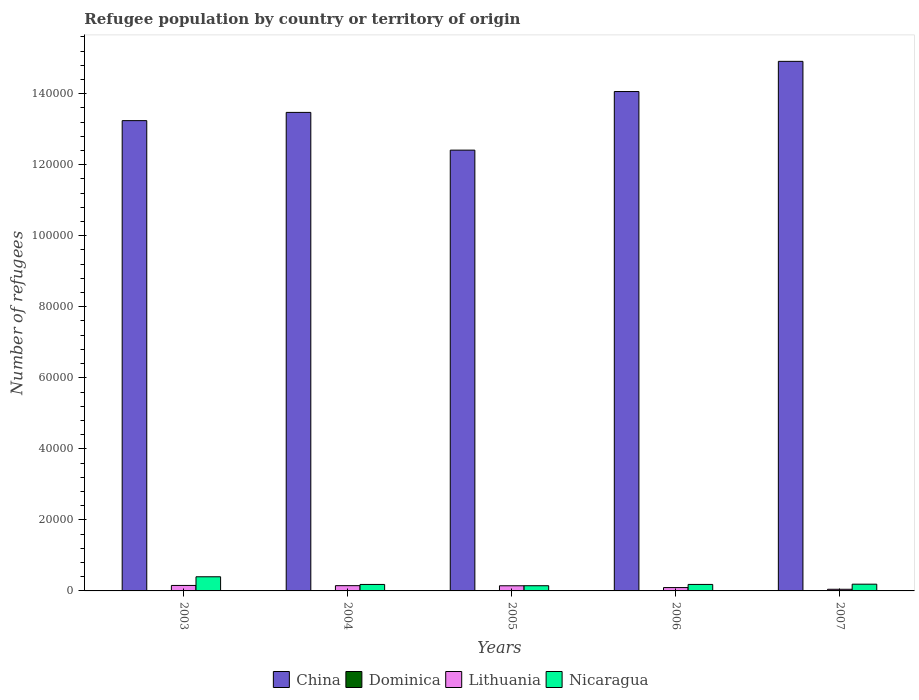How many different coloured bars are there?
Keep it short and to the point. 4. How many bars are there on the 3rd tick from the right?
Your answer should be very brief. 4. What is the number of refugees in Lithuania in 2005?
Offer a terse response. 1448. Across all years, what is the maximum number of refugees in Dominica?
Make the answer very short. 58. Across all years, what is the minimum number of refugees in Nicaragua?
Ensure brevity in your answer.  1463. In which year was the number of refugees in Dominica maximum?
Your answer should be compact. 2007. In which year was the number of refugees in China minimum?
Your answer should be compact. 2005. What is the total number of refugees in Lithuania in the graph?
Your answer should be compact. 5879. What is the difference between the number of refugees in Lithuania in 2003 and that in 2004?
Ensure brevity in your answer.  59. What is the difference between the number of refugees in Lithuania in 2007 and the number of refugees in Dominica in 2005?
Give a very brief answer. 436. What is the average number of refugees in China per year?
Provide a succinct answer. 1.36e+05. In the year 2007, what is the difference between the number of refugees in Lithuania and number of refugees in China?
Offer a terse response. -1.49e+05. In how many years, is the number of refugees in Lithuania greater than 144000?
Offer a very short reply. 0. What is the ratio of the number of refugees in Nicaragua in 2004 to that in 2007?
Provide a succinct answer. 0.96. Is the number of refugees in Lithuania in 2004 less than that in 2007?
Your answer should be compact. No. Is the difference between the number of refugees in Lithuania in 2004 and 2005 greater than the difference between the number of refugees in China in 2004 and 2005?
Offer a terse response. No. What is the difference between the highest and the lowest number of refugees in Dominica?
Provide a succinct answer. 41. In how many years, is the number of refugees in Lithuania greater than the average number of refugees in Lithuania taken over all years?
Provide a succinct answer. 3. Is the sum of the number of refugees in Lithuania in 2005 and 2007 greater than the maximum number of refugees in Nicaragua across all years?
Ensure brevity in your answer.  No. What does the 2nd bar from the left in 2004 represents?
Your response must be concise. Dominica. What does the 3rd bar from the right in 2003 represents?
Provide a succinct answer. Dominica. How many bars are there?
Offer a very short reply. 20. What is the difference between two consecutive major ticks on the Y-axis?
Provide a succinct answer. 2.00e+04. Are the values on the major ticks of Y-axis written in scientific E-notation?
Offer a very short reply. No. Does the graph contain any zero values?
Provide a succinct answer. No. Does the graph contain grids?
Make the answer very short. No. What is the title of the graph?
Give a very brief answer. Refugee population by country or territory of origin. What is the label or title of the X-axis?
Provide a succinct answer. Years. What is the label or title of the Y-axis?
Your answer should be compact. Number of refugees. What is the Number of refugees in China in 2003?
Provide a succinct answer. 1.32e+05. What is the Number of refugees of Dominica in 2003?
Provide a succinct answer. 17. What is the Number of refugees in Lithuania in 2003?
Give a very brief answer. 1541. What is the Number of refugees of Nicaragua in 2003?
Your response must be concise. 3983. What is the Number of refugees of China in 2004?
Ensure brevity in your answer.  1.35e+05. What is the Number of refugees of Lithuania in 2004?
Your answer should be very brief. 1482. What is the Number of refugees of Nicaragua in 2004?
Provide a short and direct response. 1822. What is the Number of refugees of China in 2005?
Provide a succinct answer. 1.24e+05. What is the Number of refugees in Lithuania in 2005?
Keep it short and to the point. 1448. What is the Number of refugees of Nicaragua in 2005?
Provide a succinct answer. 1463. What is the Number of refugees in China in 2006?
Give a very brief answer. 1.41e+05. What is the Number of refugees in Dominica in 2006?
Provide a succinct answer. 49. What is the Number of refugees in Lithuania in 2006?
Your answer should be compact. 942. What is the Number of refugees of Nicaragua in 2006?
Make the answer very short. 1828. What is the Number of refugees of China in 2007?
Provide a short and direct response. 1.49e+05. What is the Number of refugees of Lithuania in 2007?
Give a very brief answer. 466. What is the Number of refugees in Nicaragua in 2007?
Provide a short and direct response. 1900. Across all years, what is the maximum Number of refugees in China?
Offer a terse response. 1.49e+05. Across all years, what is the maximum Number of refugees of Lithuania?
Keep it short and to the point. 1541. Across all years, what is the maximum Number of refugees of Nicaragua?
Your answer should be very brief. 3983. Across all years, what is the minimum Number of refugees in China?
Provide a short and direct response. 1.24e+05. Across all years, what is the minimum Number of refugees of Dominica?
Your answer should be compact. 17. Across all years, what is the minimum Number of refugees in Lithuania?
Give a very brief answer. 466. Across all years, what is the minimum Number of refugees in Nicaragua?
Your response must be concise. 1463. What is the total Number of refugees of China in the graph?
Keep it short and to the point. 6.81e+05. What is the total Number of refugees in Dominica in the graph?
Offer a very short reply. 179. What is the total Number of refugees in Lithuania in the graph?
Keep it short and to the point. 5879. What is the total Number of refugees in Nicaragua in the graph?
Keep it short and to the point. 1.10e+04. What is the difference between the Number of refugees of China in 2003 and that in 2004?
Your response must be concise. -2318. What is the difference between the Number of refugees in Lithuania in 2003 and that in 2004?
Your response must be concise. 59. What is the difference between the Number of refugees of Nicaragua in 2003 and that in 2004?
Make the answer very short. 2161. What is the difference between the Number of refugees of China in 2003 and that in 2005?
Offer a terse response. 8305. What is the difference between the Number of refugees of Dominica in 2003 and that in 2005?
Provide a succinct answer. -13. What is the difference between the Number of refugees in Lithuania in 2003 and that in 2005?
Provide a succinct answer. 93. What is the difference between the Number of refugees in Nicaragua in 2003 and that in 2005?
Your answer should be very brief. 2520. What is the difference between the Number of refugees of China in 2003 and that in 2006?
Offer a very short reply. -8192. What is the difference between the Number of refugees in Dominica in 2003 and that in 2006?
Make the answer very short. -32. What is the difference between the Number of refugees of Lithuania in 2003 and that in 2006?
Give a very brief answer. 599. What is the difference between the Number of refugees in Nicaragua in 2003 and that in 2006?
Your response must be concise. 2155. What is the difference between the Number of refugees in China in 2003 and that in 2007?
Ensure brevity in your answer.  -1.67e+04. What is the difference between the Number of refugees of Dominica in 2003 and that in 2007?
Offer a terse response. -41. What is the difference between the Number of refugees of Lithuania in 2003 and that in 2007?
Your response must be concise. 1075. What is the difference between the Number of refugees in Nicaragua in 2003 and that in 2007?
Ensure brevity in your answer.  2083. What is the difference between the Number of refugees in China in 2004 and that in 2005?
Provide a short and direct response. 1.06e+04. What is the difference between the Number of refugees of Nicaragua in 2004 and that in 2005?
Your answer should be compact. 359. What is the difference between the Number of refugees in China in 2004 and that in 2006?
Provide a succinct answer. -5874. What is the difference between the Number of refugees of Lithuania in 2004 and that in 2006?
Offer a very short reply. 540. What is the difference between the Number of refugees in China in 2004 and that in 2007?
Give a very brief answer. -1.44e+04. What is the difference between the Number of refugees of Dominica in 2004 and that in 2007?
Make the answer very short. -33. What is the difference between the Number of refugees in Lithuania in 2004 and that in 2007?
Provide a short and direct response. 1016. What is the difference between the Number of refugees of Nicaragua in 2004 and that in 2007?
Keep it short and to the point. -78. What is the difference between the Number of refugees of China in 2005 and that in 2006?
Provide a succinct answer. -1.65e+04. What is the difference between the Number of refugees of Dominica in 2005 and that in 2006?
Provide a succinct answer. -19. What is the difference between the Number of refugees of Lithuania in 2005 and that in 2006?
Your answer should be very brief. 506. What is the difference between the Number of refugees in Nicaragua in 2005 and that in 2006?
Your answer should be very brief. -365. What is the difference between the Number of refugees of China in 2005 and that in 2007?
Provide a succinct answer. -2.50e+04. What is the difference between the Number of refugees of Dominica in 2005 and that in 2007?
Provide a succinct answer. -28. What is the difference between the Number of refugees in Lithuania in 2005 and that in 2007?
Your answer should be compact. 982. What is the difference between the Number of refugees of Nicaragua in 2005 and that in 2007?
Give a very brief answer. -437. What is the difference between the Number of refugees in China in 2006 and that in 2007?
Provide a short and direct response. -8497. What is the difference between the Number of refugees of Dominica in 2006 and that in 2007?
Provide a short and direct response. -9. What is the difference between the Number of refugees of Lithuania in 2006 and that in 2007?
Ensure brevity in your answer.  476. What is the difference between the Number of refugees in Nicaragua in 2006 and that in 2007?
Your answer should be very brief. -72. What is the difference between the Number of refugees in China in 2003 and the Number of refugees in Dominica in 2004?
Ensure brevity in your answer.  1.32e+05. What is the difference between the Number of refugees of China in 2003 and the Number of refugees of Lithuania in 2004?
Your response must be concise. 1.31e+05. What is the difference between the Number of refugees of China in 2003 and the Number of refugees of Nicaragua in 2004?
Your answer should be very brief. 1.31e+05. What is the difference between the Number of refugees in Dominica in 2003 and the Number of refugees in Lithuania in 2004?
Your answer should be very brief. -1465. What is the difference between the Number of refugees of Dominica in 2003 and the Number of refugees of Nicaragua in 2004?
Your answer should be compact. -1805. What is the difference between the Number of refugees of Lithuania in 2003 and the Number of refugees of Nicaragua in 2004?
Ensure brevity in your answer.  -281. What is the difference between the Number of refugees of China in 2003 and the Number of refugees of Dominica in 2005?
Provide a succinct answer. 1.32e+05. What is the difference between the Number of refugees of China in 2003 and the Number of refugees of Lithuania in 2005?
Your answer should be very brief. 1.31e+05. What is the difference between the Number of refugees in China in 2003 and the Number of refugees in Nicaragua in 2005?
Your answer should be compact. 1.31e+05. What is the difference between the Number of refugees of Dominica in 2003 and the Number of refugees of Lithuania in 2005?
Offer a terse response. -1431. What is the difference between the Number of refugees in Dominica in 2003 and the Number of refugees in Nicaragua in 2005?
Provide a short and direct response. -1446. What is the difference between the Number of refugees in Lithuania in 2003 and the Number of refugees in Nicaragua in 2005?
Your response must be concise. 78. What is the difference between the Number of refugees of China in 2003 and the Number of refugees of Dominica in 2006?
Keep it short and to the point. 1.32e+05. What is the difference between the Number of refugees of China in 2003 and the Number of refugees of Lithuania in 2006?
Your response must be concise. 1.31e+05. What is the difference between the Number of refugees in China in 2003 and the Number of refugees in Nicaragua in 2006?
Ensure brevity in your answer.  1.31e+05. What is the difference between the Number of refugees of Dominica in 2003 and the Number of refugees of Lithuania in 2006?
Give a very brief answer. -925. What is the difference between the Number of refugees of Dominica in 2003 and the Number of refugees of Nicaragua in 2006?
Your answer should be compact. -1811. What is the difference between the Number of refugees of Lithuania in 2003 and the Number of refugees of Nicaragua in 2006?
Make the answer very short. -287. What is the difference between the Number of refugees of China in 2003 and the Number of refugees of Dominica in 2007?
Provide a succinct answer. 1.32e+05. What is the difference between the Number of refugees of China in 2003 and the Number of refugees of Lithuania in 2007?
Your answer should be very brief. 1.32e+05. What is the difference between the Number of refugees of China in 2003 and the Number of refugees of Nicaragua in 2007?
Ensure brevity in your answer.  1.31e+05. What is the difference between the Number of refugees of Dominica in 2003 and the Number of refugees of Lithuania in 2007?
Offer a very short reply. -449. What is the difference between the Number of refugees in Dominica in 2003 and the Number of refugees in Nicaragua in 2007?
Ensure brevity in your answer.  -1883. What is the difference between the Number of refugees in Lithuania in 2003 and the Number of refugees in Nicaragua in 2007?
Keep it short and to the point. -359. What is the difference between the Number of refugees in China in 2004 and the Number of refugees in Dominica in 2005?
Provide a succinct answer. 1.35e+05. What is the difference between the Number of refugees of China in 2004 and the Number of refugees of Lithuania in 2005?
Your response must be concise. 1.33e+05. What is the difference between the Number of refugees of China in 2004 and the Number of refugees of Nicaragua in 2005?
Provide a short and direct response. 1.33e+05. What is the difference between the Number of refugees of Dominica in 2004 and the Number of refugees of Lithuania in 2005?
Offer a very short reply. -1423. What is the difference between the Number of refugees of Dominica in 2004 and the Number of refugees of Nicaragua in 2005?
Your answer should be very brief. -1438. What is the difference between the Number of refugees in Lithuania in 2004 and the Number of refugees in Nicaragua in 2005?
Make the answer very short. 19. What is the difference between the Number of refugees of China in 2004 and the Number of refugees of Dominica in 2006?
Provide a short and direct response. 1.35e+05. What is the difference between the Number of refugees in China in 2004 and the Number of refugees in Lithuania in 2006?
Offer a terse response. 1.34e+05. What is the difference between the Number of refugees in China in 2004 and the Number of refugees in Nicaragua in 2006?
Your answer should be very brief. 1.33e+05. What is the difference between the Number of refugees of Dominica in 2004 and the Number of refugees of Lithuania in 2006?
Your answer should be very brief. -917. What is the difference between the Number of refugees of Dominica in 2004 and the Number of refugees of Nicaragua in 2006?
Provide a short and direct response. -1803. What is the difference between the Number of refugees in Lithuania in 2004 and the Number of refugees in Nicaragua in 2006?
Your answer should be compact. -346. What is the difference between the Number of refugees in China in 2004 and the Number of refugees in Dominica in 2007?
Your answer should be very brief. 1.35e+05. What is the difference between the Number of refugees of China in 2004 and the Number of refugees of Lithuania in 2007?
Offer a terse response. 1.34e+05. What is the difference between the Number of refugees in China in 2004 and the Number of refugees in Nicaragua in 2007?
Offer a very short reply. 1.33e+05. What is the difference between the Number of refugees of Dominica in 2004 and the Number of refugees of Lithuania in 2007?
Your answer should be compact. -441. What is the difference between the Number of refugees in Dominica in 2004 and the Number of refugees in Nicaragua in 2007?
Your answer should be very brief. -1875. What is the difference between the Number of refugees of Lithuania in 2004 and the Number of refugees of Nicaragua in 2007?
Offer a terse response. -418. What is the difference between the Number of refugees in China in 2005 and the Number of refugees in Dominica in 2006?
Keep it short and to the point. 1.24e+05. What is the difference between the Number of refugees in China in 2005 and the Number of refugees in Lithuania in 2006?
Ensure brevity in your answer.  1.23e+05. What is the difference between the Number of refugees of China in 2005 and the Number of refugees of Nicaragua in 2006?
Your answer should be compact. 1.22e+05. What is the difference between the Number of refugees in Dominica in 2005 and the Number of refugees in Lithuania in 2006?
Provide a succinct answer. -912. What is the difference between the Number of refugees of Dominica in 2005 and the Number of refugees of Nicaragua in 2006?
Your answer should be very brief. -1798. What is the difference between the Number of refugees of Lithuania in 2005 and the Number of refugees of Nicaragua in 2006?
Give a very brief answer. -380. What is the difference between the Number of refugees of China in 2005 and the Number of refugees of Dominica in 2007?
Your answer should be compact. 1.24e+05. What is the difference between the Number of refugees in China in 2005 and the Number of refugees in Lithuania in 2007?
Your answer should be very brief. 1.24e+05. What is the difference between the Number of refugees in China in 2005 and the Number of refugees in Nicaragua in 2007?
Keep it short and to the point. 1.22e+05. What is the difference between the Number of refugees in Dominica in 2005 and the Number of refugees in Lithuania in 2007?
Your response must be concise. -436. What is the difference between the Number of refugees of Dominica in 2005 and the Number of refugees of Nicaragua in 2007?
Your response must be concise. -1870. What is the difference between the Number of refugees in Lithuania in 2005 and the Number of refugees in Nicaragua in 2007?
Your answer should be very brief. -452. What is the difference between the Number of refugees of China in 2006 and the Number of refugees of Dominica in 2007?
Provide a short and direct response. 1.41e+05. What is the difference between the Number of refugees in China in 2006 and the Number of refugees in Lithuania in 2007?
Your answer should be very brief. 1.40e+05. What is the difference between the Number of refugees in China in 2006 and the Number of refugees in Nicaragua in 2007?
Offer a terse response. 1.39e+05. What is the difference between the Number of refugees of Dominica in 2006 and the Number of refugees of Lithuania in 2007?
Ensure brevity in your answer.  -417. What is the difference between the Number of refugees of Dominica in 2006 and the Number of refugees of Nicaragua in 2007?
Offer a terse response. -1851. What is the difference between the Number of refugees in Lithuania in 2006 and the Number of refugees in Nicaragua in 2007?
Ensure brevity in your answer.  -958. What is the average Number of refugees in China per year?
Offer a terse response. 1.36e+05. What is the average Number of refugees in Dominica per year?
Provide a short and direct response. 35.8. What is the average Number of refugees of Lithuania per year?
Offer a terse response. 1175.8. What is the average Number of refugees of Nicaragua per year?
Ensure brevity in your answer.  2199.2. In the year 2003, what is the difference between the Number of refugees of China and Number of refugees of Dominica?
Offer a terse response. 1.32e+05. In the year 2003, what is the difference between the Number of refugees of China and Number of refugees of Lithuania?
Make the answer very short. 1.31e+05. In the year 2003, what is the difference between the Number of refugees in China and Number of refugees in Nicaragua?
Your answer should be compact. 1.28e+05. In the year 2003, what is the difference between the Number of refugees in Dominica and Number of refugees in Lithuania?
Make the answer very short. -1524. In the year 2003, what is the difference between the Number of refugees of Dominica and Number of refugees of Nicaragua?
Your answer should be very brief. -3966. In the year 2003, what is the difference between the Number of refugees in Lithuania and Number of refugees in Nicaragua?
Provide a short and direct response. -2442. In the year 2004, what is the difference between the Number of refugees in China and Number of refugees in Dominica?
Keep it short and to the point. 1.35e+05. In the year 2004, what is the difference between the Number of refugees in China and Number of refugees in Lithuania?
Give a very brief answer. 1.33e+05. In the year 2004, what is the difference between the Number of refugees of China and Number of refugees of Nicaragua?
Give a very brief answer. 1.33e+05. In the year 2004, what is the difference between the Number of refugees of Dominica and Number of refugees of Lithuania?
Your answer should be compact. -1457. In the year 2004, what is the difference between the Number of refugees in Dominica and Number of refugees in Nicaragua?
Provide a succinct answer. -1797. In the year 2004, what is the difference between the Number of refugees in Lithuania and Number of refugees in Nicaragua?
Your response must be concise. -340. In the year 2005, what is the difference between the Number of refugees of China and Number of refugees of Dominica?
Offer a terse response. 1.24e+05. In the year 2005, what is the difference between the Number of refugees of China and Number of refugees of Lithuania?
Provide a succinct answer. 1.23e+05. In the year 2005, what is the difference between the Number of refugees of China and Number of refugees of Nicaragua?
Make the answer very short. 1.23e+05. In the year 2005, what is the difference between the Number of refugees in Dominica and Number of refugees in Lithuania?
Provide a short and direct response. -1418. In the year 2005, what is the difference between the Number of refugees in Dominica and Number of refugees in Nicaragua?
Make the answer very short. -1433. In the year 2005, what is the difference between the Number of refugees of Lithuania and Number of refugees of Nicaragua?
Your response must be concise. -15. In the year 2006, what is the difference between the Number of refugees in China and Number of refugees in Dominica?
Provide a short and direct response. 1.41e+05. In the year 2006, what is the difference between the Number of refugees in China and Number of refugees in Lithuania?
Provide a short and direct response. 1.40e+05. In the year 2006, what is the difference between the Number of refugees of China and Number of refugees of Nicaragua?
Provide a succinct answer. 1.39e+05. In the year 2006, what is the difference between the Number of refugees in Dominica and Number of refugees in Lithuania?
Provide a short and direct response. -893. In the year 2006, what is the difference between the Number of refugees in Dominica and Number of refugees in Nicaragua?
Your response must be concise. -1779. In the year 2006, what is the difference between the Number of refugees in Lithuania and Number of refugees in Nicaragua?
Keep it short and to the point. -886. In the year 2007, what is the difference between the Number of refugees of China and Number of refugees of Dominica?
Make the answer very short. 1.49e+05. In the year 2007, what is the difference between the Number of refugees of China and Number of refugees of Lithuania?
Provide a short and direct response. 1.49e+05. In the year 2007, what is the difference between the Number of refugees in China and Number of refugees in Nicaragua?
Give a very brief answer. 1.47e+05. In the year 2007, what is the difference between the Number of refugees in Dominica and Number of refugees in Lithuania?
Your answer should be very brief. -408. In the year 2007, what is the difference between the Number of refugees in Dominica and Number of refugees in Nicaragua?
Your answer should be compact. -1842. In the year 2007, what is the difference between the Number of refugees of Lithuania and Number of refugees of Nicaragua?
Keep it short and to the point. -1434. What is the ratio of the Number of refugees in China in 2003 to that in 2004?
Ensure brevity in your answer.  0.98. What is the ratio of the Number of refugees in Dominica in 2003 to that in 2004?
Provide a short and direct response. 0.68. What is the ratio of the Number of refugees of Lithuania in 2003 to that in 2004?
Provide a succinct answer. 1.04. What is the ratio of the Number of refugees in Nicaragua in 2003 to that in 2004?
Your response must be concise. 2.19. What is the ratio of the Number of refugees in China in 2003 to that in 2005?
Offer a terse response. 1.07. What is the ratio of the Number of refugees in Dominica in 2003 to that in 2005?
Offer a very short reply. 0.57. What is the ratio of the Number of refugees of Lithuania in 2003 to that in 2005?
Ensure brevity in your answer.  1.06. What is the ratio of the Number of refugees in Nicaragua in 2003 to that in 2005?
Provide a short and direct response. 2.72. What is the ratio of the Number of refugees in China in 2003 to that in 2006?
Make the answer very short. 0.94. What is the ratio of the Number of refugees in Dominica in 2003 to that in 2006?
Your response must be concise. 0.35. What is the ratio of the Number of refugees of Lithuania in 2003 to that in 2006?
Ensure brevity in your answer.  1.64. What is the ratio of the Number of refugees in Nicaragua in 2003 to that in 2006?
Your answer should be very brief. 2.18. What is the ratio of the Number of refugees of China in 2003 to that in 2007?
Offer a very short reply. 0.89. What is the ratio of the Number of refugees in Dominica in 2003 to that in 2007?
Provide a succinct answer. 0.29. What is the ratio of the Number of refugees in Lithuania in 2003 to that in 2007?
Offer a very short reply. 3.31. What is the ratio of the Number of refugees in Nicaragua in 2003 to that in 2007?
Ensure brevity in your answer.  2.1. What is the ratio of the Number of refugees in China in 2004 to that in 2005?
Provide a succinct answer. 1.09. What is the ratio of the Number of refugees in Lithuania in 2004 to that in 2005?
Give a very brief answer. 1.02. What is the ratio of the Number of refugees in Nicaragua in 2004 to that in 2005?
Provide a short and direct response. 1.25. What is the ratio of the Number of refugees in China in 2004 to that in 2006?
Ensure brevity in your answer.  0.96. What is the ratio of the Number of refugees in Dominica in 2004 to that in 2006?
Provide a short and direct response. 0.51. What is the ratio of the Number of refugees of Lithuania in 2004 to that in 2006?
Keep it short and to the point. 1.57. What is the ratio of the Number of refugees in Nicaragua in 2004 to that in 2006?
Provide a short and direct response. 1. What is the ratio of the Number of refugees of China in 2004 to that in 2007?
Ensure brevity in your answer.  0.9. What is the ratio of the Number of refugees in Dominica in 2004 to that in 2007?
Provide a short and direct response. 0.43. What is the ratio of the Number of refugees in Lithuania in 2004 to that in 2007?
Ensure brevity in your answer.  3.18. What is the ratio of the Number of refugees in Nicaragua in 2004 to that in 2007?
Your answer should be compact. 0.96. What is the ratio of the Number of refugees in China in 2005 to that in 2006?
Your response must be concise. 0.88. What is the ratio of the Number of refugees in Dominica in 2005 to that in 2006?
Offer a terse response. 0.61. What is the ratio of the Number of refugees of Lithuania in 2005 to that in 2006?
Offer a very short reply. 1.54. What is the ratio of the Number of refugees of Nicaragua in 2005 to that in 2006?
Give a very brief answer. 0.8. What is the ratio of the Number of refugees in China in 2005 to that in 2007?
Your response must be concise. 0.83. What is the ratio of the Number of refugees in Dominica in 2005 to that in 2007?
Make the answer very short. 0.52. What is the ratio of the Number of refugees of Lithuania in 2005 to that in 2007?
Offer a very short reply. 3.11. What is the ratio of the Number of refugees of Nicaragua in 2005 to that in 2007?
Make the answer very short. 0.77. What is the ratio of the Number of refugees in China in 2006 to that in 2007?
Your answer should be very brief. 0.94. What is the ratio of the Number of refugees of Dominica in 2006 to that in 2007?
Give a very brief answer. 0.84. What is the ratio of the Number of refugees of Lithuania in 2006 to that in 2007?
Offer a very short reply. 2.02. What is the ratio of the Number of refugees of Nicaragua in 2006 to that in 2007?
Provide a succinct answer. 0.96. What is the difference between the highest and the second highest Number of refugees of China?
Give a very brief answer. 8497. What is the difference between the highest and the second highest Number of refugees in Dominica?
Provide a succinct answer. 9. What is the difference between the highest and the second highest Number of refugees in Lithuania?
Your answer should be very brief. 59. What is the difference between the highest and the second highest Number of refugees in Nicaragua?
Give a very brief answer. 2083. What is the difference between the highest and the lowest Number of refugees in China?
Your response must be concise. 2.50e+04. What is the difference between the highest and the lowest Number of refugees in Lithuania?
Your answer should be very brief. 1075. What is the difference between the highest and the lowest Number of refugees of Nicaragua?
Provide a succinct answer. 2520. 